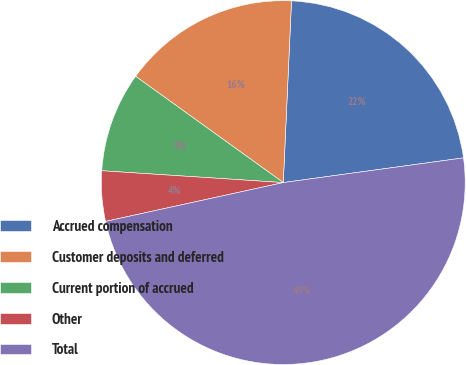Convert chart to OTSL. <chart><loc_0><loc_0><loc_500><loc_500><pie_chart><fcel>Accrued compensation<fcel>Customer deposits and deferred<fcel>Current portion of accrued<fcel>Other<fcel>Total<nl><fcel>22.11%<fcel>15.79%<fcel>8.89%<fcel>4.46%<fcel>48.74%<nl></chart> 